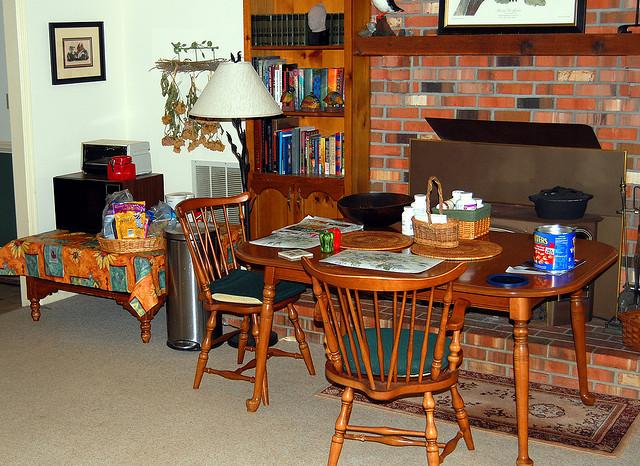Are there mats on the table?
Write a very short answer. Yes. What is the chair made of?
Give a very brief answer. Wood. What is inside of the fireplace area?
Quick response, please. Pot. 